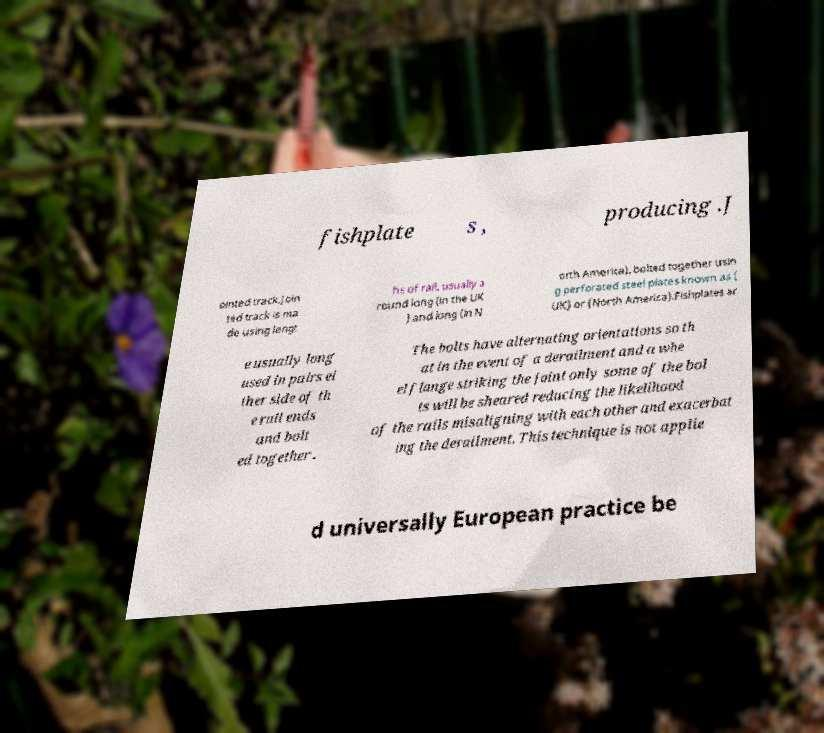Could you extract and type out the text from this image? fishplate s , producing .J ointed track.Join ted track is ma de using lengt hs of rail, usually a round long (in the UK ) and long (in N orth America), bolted together usin g perforated steel plates known as ( UK) or (North America).Fishplates ar e usually long used in pairs ei ther side of th e rail ends and bolt ed together . The bolts have alternating orientations so th at in the event of a derailment and a whe el flange striking the joint only some of the bol ts will be sheared reducing the likelihood of the rails misaligning with each other and exacerbat ing the derailment. This technique is not applie d universally European practice be 